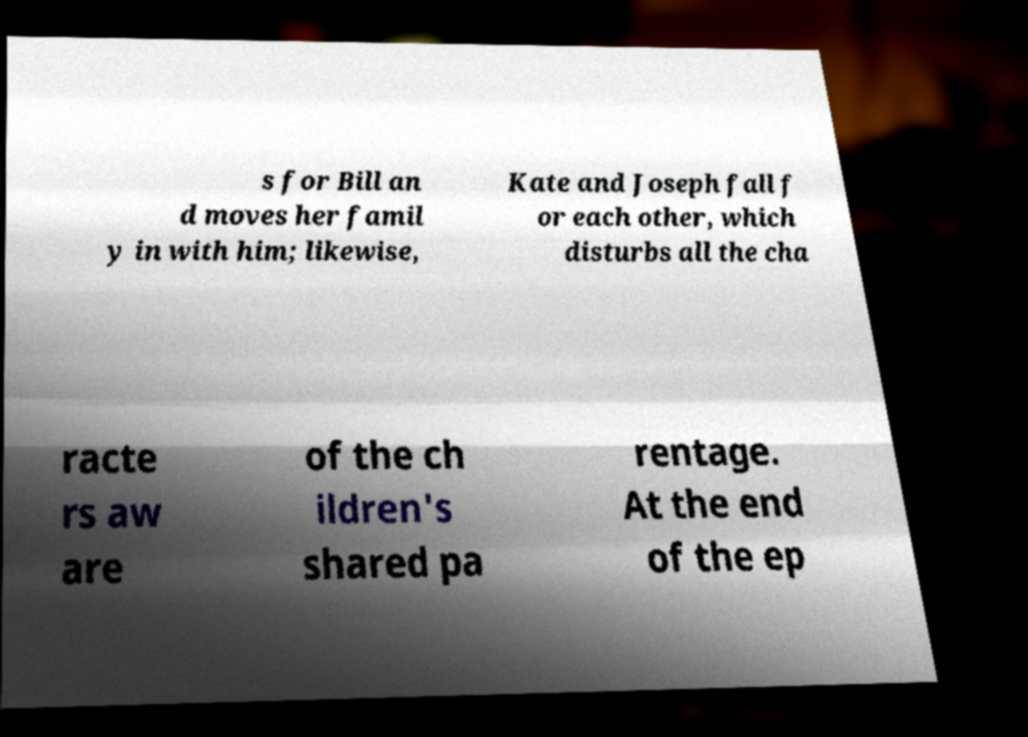Could you extract and type out the text from this image? s for Bill an d moves her famil y in with him; likewise, Kate and Joseph fall f or each other, which disturbs all the cha racte rs aw are of the ch ildren's shared pa rentage. At the end of the ep 